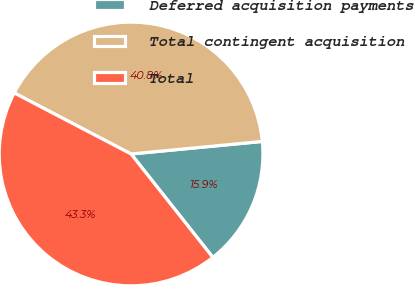Convert chart. <chart><loc_0><loc_0><loc_500><loc_500><pie_chart><fcel>Deferred acquisition payments<fcel>Total contingent acquisition<fcel>Total<nl><fcel>15.87%<fcel>40.82%<fcel>43.31%<nl></chart> 